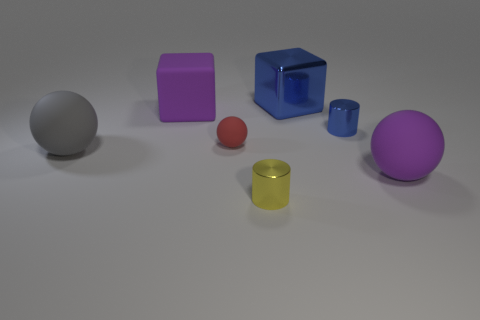Add 3 metal cylinders. How many objects exist? 10 Subtract all spheres. How many objects are left? 4 Subtract all brown things. Subtract all blocks. How many objects are left? 5 Add 2 red spheres. How many red spheres are left? 3 Add 6 large blue shiny balls. How many large blue shiny balls exist? 6 Subtract 0 yellow cubes. How many objects are left? 7 